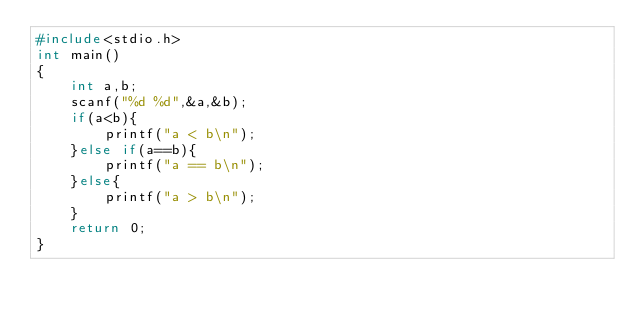<code> <loc_0><loc_0><loc_500><loc_500><_C_>#include<stdio.h>
int main()
{
	int a,b;
	scanf("%d %d",&a,&b);
	if(a<b){
		printf("a < b\n");
	}else if(a==b){
		printf("a == b\n");
	}else{
		printf("a > b\n");
	}
	return 0;
}</code> 